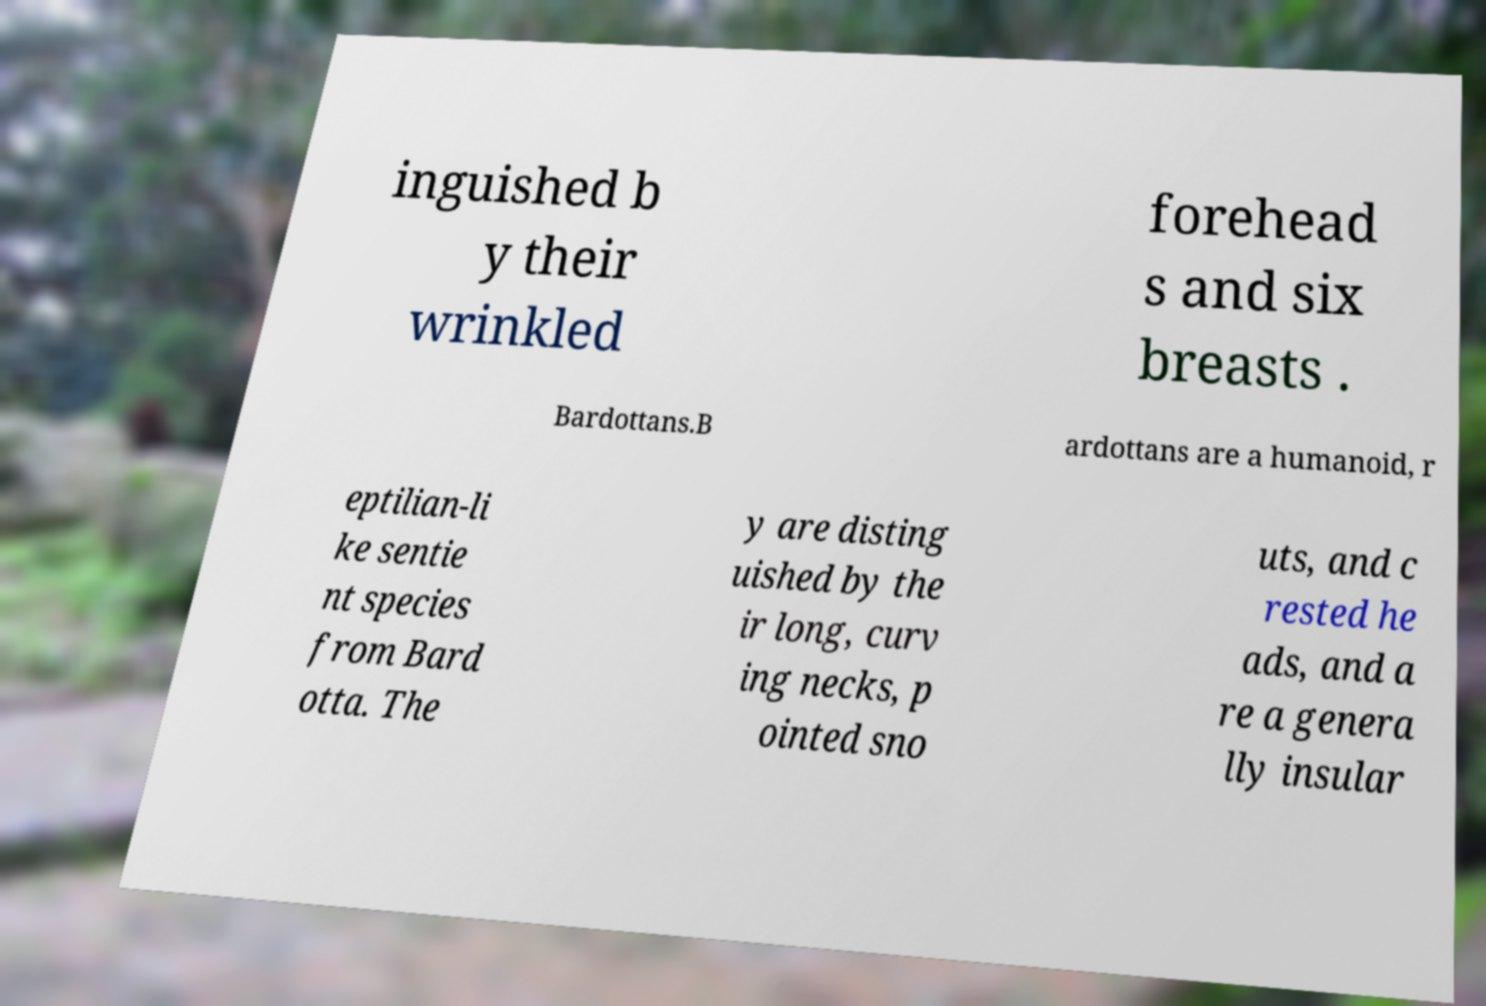For documentation purposes, I need the text within this image transcribed. Could you provide that? inguished b y their wrinkled forehead s and six breasts . Bardottans.B ardottans are a humanoid, r eptilian-li ke sentie nt species from Bard otta. The y are disting uished by the ir long, curv ing necks, p ointed sno uts, and c rested he ads, and a re a genera lly insular 